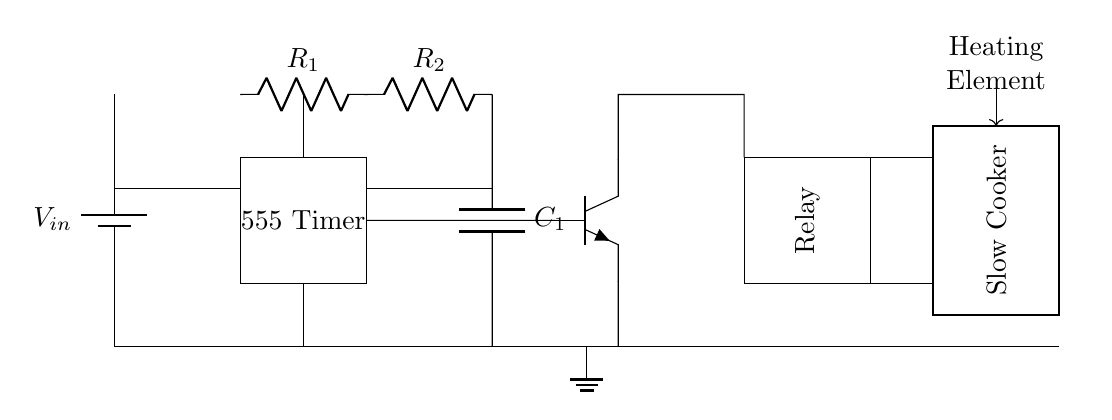What is the function of the 555 Timer in this circuit? The 555 Timer is used to control the timing aspects of the circuit, enabling it to switch the relay on and off at specific intervals based on the resistors and capacitor connected to it.
Answer: Control What do R1 and R2 represent? R1 and R2 are resistors that form part of the timing network for the 555 Timer, which determines the duration for which the heating element in the slow cooker operates.
Answer: Resistors Which component provides the necessary delay before the slow cooker activates? The combination of the resistors R1, R2, and the capacitor C1 create the timing delay that activates the slow cooker after a specific period.
Answer: C1 How many primary components are there in this circuit? The primary components include one battery, one 555 Timer, two resistors (R1 and R2), one capacitor (C1), one transistor, one relay, and one slow cooker. In total, there are seven main components.
Answer: Seven What type of control does this circuit employ to turn on the heating element? The circuit employs relay control, where the relay is activated based on the output from the 555 Timer circuit. When the timer completes its cycle, it energizes the relay to power the heating element.
Answer: Relay control How does the transistor fit into the function of the circuit? The transistor acts as a switch that allows the current to flow to the relay when the 555 Timer sends a signal, thereby controlling the power to the slow cooker based on the timer settings.
Answer: Switch 